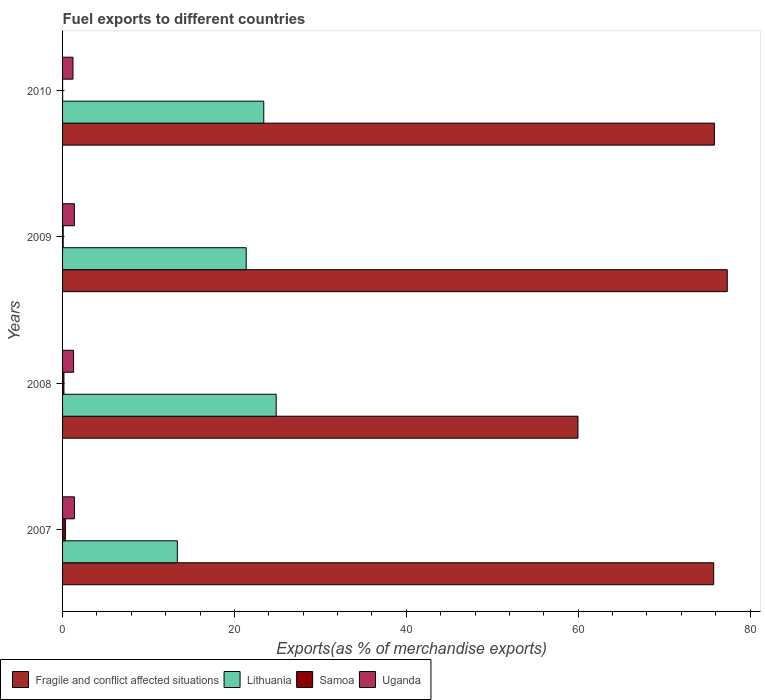How many groups of bars are there?
Your answer should be compact. 4. Are the number of bars per tick equal to the number of legend labels?
Give a very brief answer. Yes. How many bars are there on the 3rd tick from the top?
Offer a terse response. 4. How many bars are there on the 2nd tick from the bottom?
Give a very brief answer. 4. What is the label of the 2nd group of bars from the top?
Give a very brief answer. 2009. In how many cases, is the number of bars for a given year not equal to the number of legend labels?
Provide a succinct answer. 0. What is the percentage of exports to different countries in Fragile and conflict affected situations in 2009?
Your response must be concise. 77.35. Across all years, what is the maximum percentage of exports to different countries in Uganda?
Your answer should be very brief. 1.38. Across all years, what is the minimum percentage of exports to different countries in Uganda?
Make the answer very short. 1.21. In which year was the percentage of exports to different countries in Fragile and conflict affected situations minimum?
Provide a succinct answer. 2008. What is the total percentage of exports to different countries in Uganda in the graph?
Your answer should be very brief. 5.24. What is the difference between the percentage of exports to different countries in Fragile and conflict affected situations in 2007 and that in 2010?
Your answer should be compact. -0.08. What is the difference between the percentage of exports to different countries in Samoa in 2009 and the percentage of exports to different countries in Fragile and conflict affected situations in 2008?
Provide a succinct answer. -59.9. What is the average percentage of exports to different countries in Lithuania per year?
Offer a terse response. 20.75. In the year 2010, what is the difference between the percentage of exports to different countries in Fragile and conflict affected situations and percentage of exports to different countries in Lithuania?
Give a very brief answer. 52.44. In how many years, is the percentage of exports to different countries in Samoa greater than 72 %?
Your answer should be very brief. 0. What is the ratio of the percentage of exports to different countries in Lithuania in 2007 to that in 2010?
Offer a very short reply. 0.57. Is the difference between the percentage of exports to different countries in Fragile and conflict affected situations in 2007 and 2009 greater than the difference between the percentage of exports to different countries in Lithuania in 2007 and 2009?
Provide a succinct answer. Yes. What is the difference between the highest and the second highest percentage of exports to different countries in Samoa?
Make the answer very short. 0.17. What is the difference between the highest and the lowest percentage of exports to different countries in Fragile and conflict affected situations?
Offer a terse response. 17.37. In how many years, is the percentage of exports to different countries in Uganda greater than the average percentage of exports to different countries in Uganda taken over all years?
Give a very brief answer. 2. Is it the case that in every year, the sum of the percentage of exports to different countries in Uganda and percentage of exports to different countries in Samoa is greater than the sum of percentage of exports to different countries in Fragile and conflict affected situations and percentage of exports to different countries in Lithuania?
Your answer should be compact. No. What does the 3rd bar from the top in 2007 represents?
Your response must be concise. Lithuania. What does the 3rd bar from the bottom in 2007 represents?
Ensure brevity in your answer.  Samoa. What is the difference between two consecutive major ticks on the X-axis?
Ensure brevity in your answer.  20. Does the graph contain grids?
Ensure brevity in your answer.  No. Where does the legend appear in the graph?
Your response must be concise. Bottom left. What is the title of the graph?
Offer a very short reply. Fuel exports to different countries. What is the label or title of the X-axis?
Your response must be concise. Exports(as % of merchandise exports). What is the Exports(as % of merchandise exports) of Fragile and conflict affected situations in 2007?
Ensure brevity in your answer.  75.77. What is the Exports(as % of merchandise exports) of Lithuania in 2007?
Your response must be concise. 13.36. What is the Exports(as % of merchandise exports) of Samoa in 2007?
Ensure brevity in your answer.  0.33. What is the Exports(as % of merchandise exports) in Uganda in 2007?
Ensure brevity in your answer.  1.38. What is the Exports(as % of merchandise exports) in Fragile and conflict affected situations in 2008?
Offer a very short reply. 59.98. What is the Exports(as % of merchandise exports) in Lithuania in 2008?
Provide a short and direct response. 24.86. What is the Exports(as % of merchandise exports) of Samoa in 2008?
Provide a short and direct response. 0.16. What is the Exports(as % of merchandise exports) in Uganda in 2008?
Ensure brevity in your answer.  1.28. What is the Exports(as % of merchandise exports) of Fragile and conflict affected situations in 2009?
Your answer should be compact. 77.35. What is the Exports(as % of merchandise exports) of Lithuania in 2009?
Offer a terse response. 21.37. What is the Exports(as % of merchandise exports) in Samoa in 2009?
Provide a succinct answer. 0.07. What is the Exports(as % of merchandise exports) of Uganda in 2009?
Provide a short and direct response. 1.38. What is the Exports(as % of merchandise exports) in Fragile and conflict affected situations in 2010?
Offer a very short reply. 75.85. What is the Exports(as % of merchandise exports) of Lithuania in 2010?
Ensure brevity in your answer.  23.41. What is the Exports(as % of merchandise exports) of Samoa in 2010?
Ensure brevity in your answer.  0. What is the Exports(as % of merchandise exports) of Uganda in 2010?
Provide a succinct answer. 1.21. Across all years, what is the maximum Exports(as % of merchandise exports) of Fragile and conflict affected situations?
Provide a short and direct response. 77.35. Across all years, what is the maximum Exports(as % of merchandise exports) of Lithuania?
Your answer should be compact. 24.86. Across all years, what is the maximum Exports(as % of merchandise exports) of Samoa?
Your answer should be very brief. 0.33. Across all years, what is the maximum Exports(as % of merchandise exports) in Uganda?
Provide a succinct answer. 1.38. Across all years, what is the minimum Exports(as % of merchandise exports) in Fragile and conflict affected situations?
Make the answer very short. 59.98. Across all years, what is the minimum Exports(as % of merchandise exports) in Lithuania?
Make the answer very short. 13.36. Across all years, what is the minimum Exports(as % of merchandise exports) in Samoa?
Ensure brevity in your answer.  0. Across all years, what is the minimum Exports(as % of merchandise exports) of Uganda?
Provide a short and direct response. 1.21. What is the total Exports(as % of merchandise exports) in Fragile and conflict affected situations in the graph?
Provide a succinct answer. 288.94. What is the total Exports(as % of merchandise exports) of Lithuania in the graph?
Keep it short and to the point. 83. What is the total Exports(as % of merchandise exports) in Samoa in the graph?
Offer a terse response. 0.57. What is the total Exports(as % of merchandise exports) in Uganda in the graph?
Offer a terse response. 5.24. What is the difference between the Exports(as % of merchandise exports) in Fragile and conflict affected situations in 2007 and that in 2008?
Give a very brief answer. 15.8. What is the difference between the Exports(as % of merchandise exports) in Lithuania in 2007 and that in 2008?
Offer a terse response. -11.5. What is the difference between the Exports(as % of merchandise exports) of Samoa in 2007 and that in 2008?
Your answer should be compact. 0.17. What is the difference between the Exports(as % of merchandise exports) in Uganda in 2007 and that in 2008?
Provide a succinct answer. 0.1. What is the difference between the Exports(as % of merchandise exports) of Fragile and conflict affected situations in 2007 and that in 2009?
Keep it short and to the point. -1.58. What is the difference between the Exports(as % of merchandise exports) in Lithuania in 2007 and that in 2009?
Give a very brief answer. -8.02. What is the difference between the Exports(as % of merchandise exports) in Samoa in 2007 and that in 2009?
Your response must be concise. 0.26. What is the difference between the Exports(as % of merchandise exports) of Uganda in 2007 and that in 2009?
Give a very brief answer. 0. What is the difference between the Exports(as % of merchandise exports) in Fragile and conflict affected situations in 2007 and that in 2010?
Make the answer very short. -0.08. What is the difference between the Exports(as % of merchandise exports) in Lithuania in 2007 and that in 2010?
Your answer should be very brief. -10.06. What is the difference between the Exports(as % of merchandise exports) of Samoa in 2007 and that in 2010?
Give a very brief answer. 0.33. What is the difference between the Exports(as % of merchandise exports) of Uganda in 2007 and that in 2010?
Offer a very short reply. 0.17. What is the difference between the Exports(as % of merchandise exports) in Fragile and conflict affected situations in 2008 and that in 2009?
Offer a very short reply. -17.37. What is the difference between the Exports(as % of merchandise exports) of Lithuania in 2008 and that in 2009?
Your answer should be very brief. 3.49. What is the difference between the Exports(as % of merchandise exports) of Samoa in 2008 and that in 2009?
Your answer should be compact. 0.09. What is the difference between the Exports(as % of merchandise exports) of Uganda in 2008 and that in 2009?
Your answer should be compact. -0.1. What is the difference between the Exports(as % of merchandise exports) of Fragile and conflict affected situations in 2008 and that in 2010?
Your answer should be very brief. -15.88. What is the difference between the Exports(as % of merchandise exports) of Lithuania in 2008 and that in 2010?
Keep it short and to the point. 1.45. What is the difference between the Exports(as % of merchandise exports) in Samoa in 2008 and that in 2010?
Provide a short and direct response. 0.16. What is the difference between the Exports(as % of merchandise exports) of Uganda in 2008 and that in 2010?
Your response must be concise. 0.07. What is the difference between the Exports(as % of merchandise exports) in Fragile and conflict affected situations in 2009 and that in 2010?
Keep it short and to the point. 1.5. What is the difference between the Exports(as % of merchandise exports) in Lithuania in 2009 and that in 2010?
Offer a very short reply. -2.04. What is the difference between the Exports(as % of merchandise exports) in Samoa in 2009 and that in 2010?
Provide a short and direct response. 0.07. What is the difference between the Exports(as % of merchandise exports) in Uganda in 2009 and that in 2010?
Your answer should be very brief. 0.17. What is the difference between the Exports(as % of merchandise exports) in Fragile and conflict affected situations in 2007 and the Exports(as % of merchandise exports) in Lithuania in 2008?
Keep it short and to the point. 50.91. What is the difference between the Exports(as % of merchandise exports) in Fragile and conflict affected situations in 2007 and the Exports(as % of merchandise exports) in Samoa in 2008?
Give a very brief answer. 75.61. What is the difference between the Exports(as % of merchandise exports) in Fragile and conflict affected situations in 2007 and the Exports(as % of merchandise exports) in Uganda in 2008?
Your answer should be compact. 74.49. What is the difference between the Exports(as % of merchandise exports) of Lithuania in 2007 and the Exports(as % of merchandise exports) of Samoa in 2008?
Your response must be concise. 13.2. What is the difference between the Exports(as % of merchandise exports) in Lithuania in 2007 and the Exports(as % of merchandise exports) in Uganda in 2008?
Your answer should be compact. 12.08. What is the difference between the Exports(as % of merchandise exports) of Samoa in 2007 and the Exports(as % of merchandise exports) of Uganda in 2008?
Your response must be concise. -0.95. What is the difference between the Exports(as % of merchandise exports) in Fragile and conflict affected situations in 2007 and the Exports(as % of merchandise exports) in Lithuania in 2009?
Make the answer very short. 54.4. What is the difference between the Exports(as % of merchandise exports) in Fragile and conflict affected situations in 2007 and the Exports(as % of merchandise exports) in Samoa in 2009?
Offer a terse response. 75.7. What is the difference between the Exports(as % of merchandise exports) of Fragile and conflict affected situations in 2007 and the Exports(as % of merchandise exports) of Uganda in 2009?
Give a very brief answer. 74.4. What is the difference between the Exports(as % of merchandise exports) of Lithuania in 2007 and the Exports(as % of merchandise exports) of Samoa in 2009?
Give a very brief answer. 13.28. What is the difference between the Exports(as % of merchandise exports) of Lithuania in 2007 and the Exports(as % of merchandise exports) of Uganda in 2009?
Offer a very short reply. 11.98. What is the difference between the Exports(as % of merchandise exports) in Samoa in 2007 and the Exports(as % of merchandise exports) in Uganda in 2009?
Give a very brief answer. -1.04. What is the difference between the Exports(as % of merchandise exports) in Fragile and conflict affected situations in 2007 and the Exports(as % of merchandise exports) in Lithuania in 2010?
Provide a succinct answer. 52.36. What is the difference between the Exports(as % of merchandise exports) of Fragile and conflict affected situations in 2007 and the Exports(as % of merchandise exports) of Samoa in 2010?
Your answer should be compact. 75.77. What is the difference between the Exports(as % of merchandise exports) in Fragile and conflict affected situations in 2007 and the Exports(as % of merchandise exports) in Uganda in 2010?
Offer a terse response. 74.56. What is the difference between the Exports(as % of merchandise exports) in Lithuania in 2007 and the Exports(as % of merchandise exports) in Samoa in 2010?
Provide a succinct answer. 13.35. What is the difference between the Exports(as % of merchandise exports) of Lithuania in 2007 and the Exports(as % of merchandise exports) of Uganda in 2010?
Offer a very short reply. 12.15. What is the difference between the Exports(as % of merchandise exports) in Samoa in 2007 and the Exports(as % of merchandise exports) in Uganda in 2010?
Give a very brief answer. -0.88. What is the difference between the Exports(as % of merchandise exports) in Fragile and conflict affected situations in 2008 and the Exports(as % of merchandise exports) in Lithuania in 2009?
Make the answer very short. 38.6. What is the difference between the Exports(as % of merchandise exports) in Fragile and conflict affected situations in 2008 and the Exports(as % of merchandise exports) in Samoa in 2009?
Provide a short and direct response. 59.9. What is the difference between the Exports(as % of merchandise exports) in Fragile and conflict affected situations in 2008 and the Exports(as % of merchandise exports) in Uganda in 2009?
Your response must be concise. 58.6. What is the difference between the Exports(as % of merchandise exports) in Lithuania in 2008 and the Exports(as % of merchandise exports) in Samoa in 2009?
Ensure brevity in your answer.  24.79. What is the difference between the Exports(as % of merchandise exports) of Lithuania in 2008 and the Exports(as % of merchandise exports) of Uganda in 2009?
Offer a terse response. 23.49. What is the difference between the Exports(as % of merchandise exports) in Samoa in 2008 and the Exports(as % of merchandise exports) in Uganda in 2009?
Provide a succinct answer. -1.22. What is the difference between the Exports(as % of merchandise exports) of Fragile and conflict affected situations in 2008 and the Exports(as % of merchandise exports) of Lithuania in 2010?
Keep it short and to the point. 36.56. What is the difference between the Exports(as % of merchandise exports) of Fragile and conflict affected situations in 2008 and the Exports(as % of merchandise exports) of Samoa in 2010?
Keep it short and to the point. 59.97. What is the difference between the Exports(as % of merchandise exports) of Fragile and conflict affected situations in 2008 and the Exports(as % of merchandise exports) of Uganda in 2010?
Keep it short and to the point. 58.77. What is the difference between the Exports(as % of merchandise exports) of Lithuania in 2008 and the Exports(as % of merchandise exports) of Samoa in 2010?
Provide a short and direct response. 24.86. What is the difference between the Exports(as % of merchandise exports) of Lithuania in 2008 and the Exports(as % of merchandise exports) of Uganda in 2010?
Make the answer very short. 23.65. What is the difference between the Exports(as % of merchandise exports) in Samoa in 2008 and the Exports(as % of merchandise exports) in Uganda in 2010?
Offer a very short reply. -1.05. What is the difference between the Exports(as % of merchandise exports) of Fragile and conflict affected situations in 2009 and the Exports(as % of merchandise exports) of Lithuania in 2010?
Ensure brevity in your answer.  53.93. What is the difference between the Exports(as % of merchandise exports) in Fragile and conflict affected situations in 2009 and the Exports(as % of merchandise exports) in Samoa in 2010?
Ensure brevity in your answer.  77.34. What is the difference between the Exports(as % of merchandise exports) of Fragile and conflict affected situations in 2009 and the Exports(as % of merchandise exports) of Uganda in 2010?
Provide a succinct answer. 76.14. What is the difference between the Exports(as % of merchandise exports) of Lithuania in 2009 and the Exports(as % of merchandise exports) of Samoa in 2010?
Keep it short and to the point. 21.37. What is the difference between the Exports(as % of merchandise exports) in Lithuania in 2009 and the Exports(as % of merchandise exports) in Uganda in 2010?
Your answer should be very brief. 20.16. What is the difference between the Exports(as % of merchandise exports) of Samoa in 2009 and the Exports(as % of merchandise exports) of Uganda in 2010?
Keep it short and to the point. -1.14. What is the average Exports(as % of merchandise exports) of Fragile and conflict affected situations per year?
Your answer should be compact. 72.24. What is the average Exports(as % of merchandise exports) of Lithuania per year?
Your answer should be very brief. 20.75. What is the average Exports(as % of merchandise exports) of Samoa per year?
Provide a succinct answer. 0.14. What is the average Exports(as % of merchandise exports) in Uganda per year?
Provide a succinct answer. 1.31. In the year 2007, what is the difference between the Exports(as % of merchandise exports) in Fragile and conflict affected situations and Exports(as % of merchandise exports) in Lithuania?
Keep it short and to the point. 62.41. In the year 2007, what is the difference between the Exports(as % of merchandise exports) of Fragile and conflict affected situations and Exports(as % of merchandise exports) of Samoa?
Ensure brevity in your answer.  75.44. In the year 2007, what is the difference between the Exports(as % of merchandise exports) in Fragile and conflict affected situations and Exports(as % of merchandise exports) in Uganda?
Offer a terse response. 74.39. In the year 2007, what is the difference between the Exports(as % of merchandise exports) in Lithuania and Exports(as % of merchandise exports) in Samoa?
Your response must be concise. 13.02. In the year 2007, what is the difference between the Exports(as % of merchandise exports) of Lithuania and Exports(as % of merchandise exports) of Uganda?
Provide a succinct answer. 11.98. In the year 2007, what is the difference between the Exports(as % of merchandise exports) of Samoa and Exports(as % of merchandise exports) of Uganda?
Your response must be concise. -1.05. In the year 2008, what is the difference between the Exports(as % of merchandise exports) of Fragile and conflict affected situations and Exports(as % of merchandise exports) of Lithuania?
Offer a very short reply. 35.12. In the year 2008, what is the difference between the Exports(as % of merchandise exports) in Fragile and conflict affected situations and Exports(as % of merchandise exports) in Samoa?
Make the answer very short. 59.82. In the year 2008, what is the difference between the Exports(as % of merchandise exports) in Fragile and conflict affected situations and Exports(as % of merchandise exports) in Uganda?
Make the answer very short. 58.7. In the year 2008, what is the difference between the Exports(as % of merchandise exports) of Lithuania and Exports(as % of merchandise exports) of Samoa?
Your answer should be compact. 24.7. In the year 2008, what is the difference between the Exports(as % of merchandise exports) in Lithuania and Exports(as % of merchandise exports) in Uganda?
Offer a very short reply. 23.58. In the year 2008, what is the difference between the Exports(as % of merchandise exports) in Samoa and Exports(as % of merchandise exports) in Uganda?
Provide a short and direct response. -1.12. In the year 2009, what is the difference between the Exports(as % of merchandise exports) in Fragile and conflict affected situations and Exports(as % of merchandise exports) in Lithuania?
Your answer should be compact. 55.98. In the year 2009, what is the difference between the Exports(as % of merchandise exports) of Fragile and conflict affected situations and Exports(as % of merchandise exports) of Samoa?
Your answer should be compact. 77.28. In the year 2009, what is the difference between the Exports(as % of merchandise exports) of Fragile and conflict affected situations and Exports(as % of merchandise exports) of Uganda?
Your response must be concise. 75.97. In the year 2009, what is the difference between the Exports(as % of merchandise exports) of Lithuania and Exports(as % of merchandise exports) of Samoa?
Your response must be concise. 21.3. In the year 2009, what is the difference between the Exports(as % of merchandise exports) in Lithuania and Exports(as % of merchandise exports) in Uganda?
Provide a short and direct response. 20. In the year 2009, what is the difference between the Exports(as % of merchandise exports) of Samoa and Exports(as % of merchandise exports) of Uganda?
Offer a very short reply. -1.3. In the year 2010, what is the difference between the Exports(as % of merchandise exports) in Fragile and conflict affected situations and Exports(as % of merchandise exports) in Lithuania?
Offer a very short reply. 52.44. In the year 2010, what is the difference between the Exports(as % of merchandise exports) of Fragile and conflict affected situations and Exports(as % of merchandise exports) of Samoa?
Give a very brief answer. 75.85. In the year 2010, what is the difference between the Exports(as % of merchandise exports) of Fragile and conflict affected situations and Exports(as % of merchandise exports) of Uganda?
Keep it short and to the point. 74.64. In the year 2010, what is the difference between the Exports(as % of merchandise exports) of Lithuania and Exports(as % of merchandise exports) of Samoa?
Your answer should be compact. 23.41. In the year 2010, what is the difference between the Exports(as % of merchandise exports) of Lithuania and Exports(as % of merchandise exports) of Uganda?
Ensure brevity in your answer.  22.2. In the year 2010, what is the difference between the Exports(as % of merchandise exports) in Samoa and Exports(as % of merchandise exports) in Uganda?
Provide a succinct answer. -1.21. What is the ratio of the Exports(as % of merchandise exports) in Fragile and conflict affected situations in 2007 to that in 2008?
Your answer should be very brief. 1.26. What is the ratio of the Exports(as % of merchandise exports) of Lithuania in 2007 to that in 2008?
Provide a succinct answer. 0.54. What is the ratio of the Exports(as % of merchandise exports) in Samoa in 2007 to that in 2008?
Make the answer very short. 2.08. What is the ratio of the Exports(as % of merchandise exports) in Uganda in 2007 to that in 2008?
Ensure brevity in your answer.  1.08. What is the ratio of the Exports(as % of merchandise exports) in Fragile and conflict affected situations in 2007 to that in 2009?
Offer a very short reply. 0.98. What is the ratio of the Exports(as % of merchandise exports) in Samoa in 2007 to that in 2009?
Make the answer very short. 4.69. What is the ratio of the Exports(as % of merchandise exports) in Lithuania in 2007 to that in 2010?
Provide a succinct answer. 0.57. What is the ratio of the Exports(as % of merchandise exports) of Samoa in 2007 to that in 2010?
Keep it short and to the point. 107.62. What is the ratio of the Exports(as % of merchandise exports) in Uganda in 2007 to that in 2010?
Offer a terse response. 1.14. What is the ratio of the Exports(as % of merchandise exports) in Fragile and conflict affected situations in 2008 to that in 2009?
Offer a terse response. 0.78. What is the ratio of the Exports(as % of merchandise exports) in Lithuania in 2008 to that in 2009?
Make the answer very short. 1.16. What is the ratio of the Exports(as % of merchandise exports) of Samoa in 2008 to that in 2009?
Give a very brief answer. 2.25. What is the ratio of the Exports(as % of merchandise exports) of Uganda in 2008 to that in 2009?
Offer a very short reply. 0.93. What is the ratio of the Exports(as % of merchandise exports) in Fragile and conflict affected situations in 2008 to that in 2010?
Keep it short and to the point. 0.79. What is the ratio of the Exports(as % of merchandise exports) in Lithuania in 2008 to that in 2010?
Make the answer very short. 1.06. What is the ratio of the Exports(as % of merchandise exports) in Samoa in 2008 to that in 2010?
Your answer should be very brief. 51.66. What is the ratio of the Exports(as % of merchandise exports) of Uganda in 2008 to that in 2010?
Provide a succinct answer. 1.06. What is the ratio of the Exports(as % of merchandise exports) of Fragile and conflict affected situations in 2009 to that in 2010?
Provide a short and direct response. 1.02. What is the ratio of the Exports(as % of merchandise exports) of Lithuania in 2009 to that in 2010?
Provide a short and direct response. 0.91. What is the ratio of the Exports(as % of merchandise exports) of Samoa in 2009 to that in 2010?
Offer a terse response. 22.94. What is the ratio of the Exports(as % of merchandise exports) in Uganda in 2009 to that in 2010?
Your answer should be compact. 1.14. What is the difference between the highest and the second highest Exports(as % of merchandise exports) of Fragile and conflict affected situations?
Your response must be concise. 1.5. What is the difference between the highest and the second highest Exports(as % of merchandise exports) in Lithuania?
Make the answer very short. 1.45. What is the difference between the highest and the second highest Exports(as % of merchandise exports) of Samoa?
Give a very brief answer. 0.17. What is the difference between the highest and the second highest Exports(as % of merchandise exports) of Uganda?
Your response must be concise. 0. What is the difference between the highest and the lowest Exports(as % of merchandise exports) in Fragile and conflict affected situations?
Your answer should be compact. 17.37. What is the difference between the highest and the lowest Exports(as % of merchandise exports) of Lithuania?
Provide a succinct answer. 11.5. What is the difference between the highest and the lowest Exports(as % of merchandise exports) of Samoa?
Ensure brevity in your answer.  0.33. What is the difference between the highest and the lowest Exports(as % of merchandise exports) in Uganda?
Give a very brief answer. 0.17. 